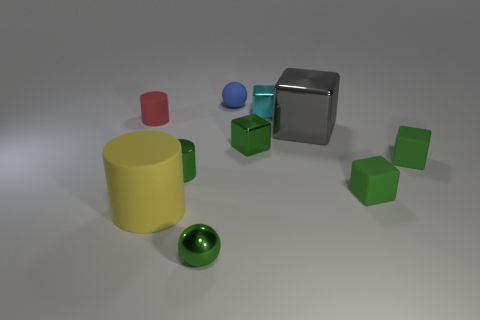Is there another thing that has the same material as the red thing?
Your answer should be very brief. Yes. There is a gray metal thing; is its shape the same as the small green metallic thing right of the green sphere?
Provide a succinct answer. Yes. How many tiny objects are both in front of the tiny red cylinder and on the left side of the small blue matte thing?
Offer a very short reply. 2. Do the big gray thing and the green block that is left of the small cyan object have the same material?
Offer a very short reply. Yes. Are there an equal number of big objects behind the tiny cyan cube and small green matte spheres?
Offer a terse response. Yes. There is a ball that is behind the red matte thing; what is its color?
Your answer should be compact. Blue. What number of other objects are the same color as the small shiny cylinder?
Ensure brevity in your answer.  4. There is a blue rubber object behind the green metal cube; is it the same size as the big cylinder?
Give a very brief answer. No. There is a large yellow thing that is in front of the small blue sphere; what material is it?
Provide a succinct answer. Rubber. What number of shiny objects are either yellow objects or small cyan things?
Your answer should be very brief. 1. 